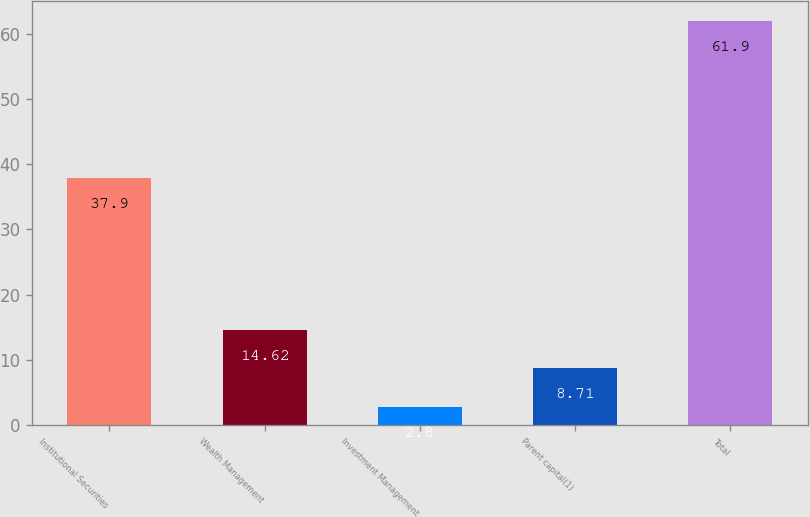Convert chart to OTSL. <chart><loc_0><loc_0><loc_500><loc_500><bar_chart><fcel>Institutional Securities<fcel>Wealth Management<fcel>Investment Management<fcel>Parent capital(1)<fcel>Total<nl><fcel>37.9<fcel>14.62<fcel>2.8<fcel>8.71<fcel>61.9<nl></chart> 